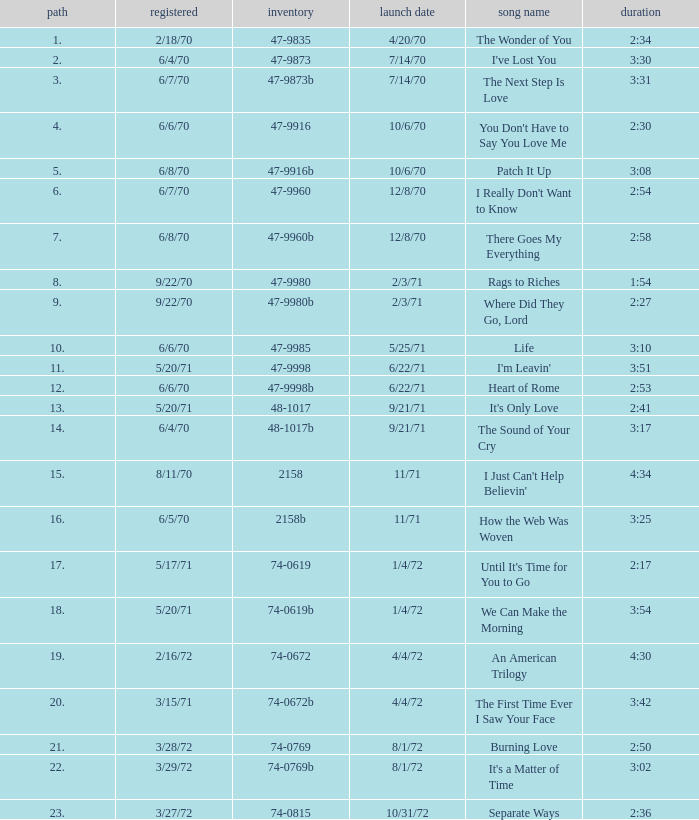Which song was released 12/8/70 with a time of 2:54? I Really Don't Want to Know. 